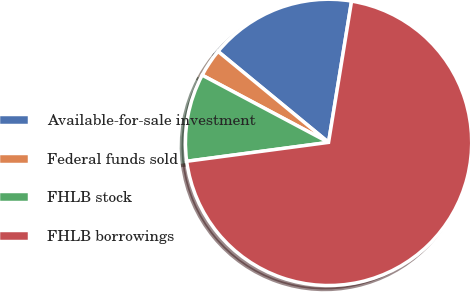<chart> <loc_0><loc_0><loc_500><loc_500><pie_chart><fcel>Available-for-sale investment<fcel>Federal funds sold<fcel>FHLB stock<fcel>FHLB borrowings<nl><fcel>16.61%<fcel>3.18%<fcel>9.89%<fcel>70.32%<nl></chart> 